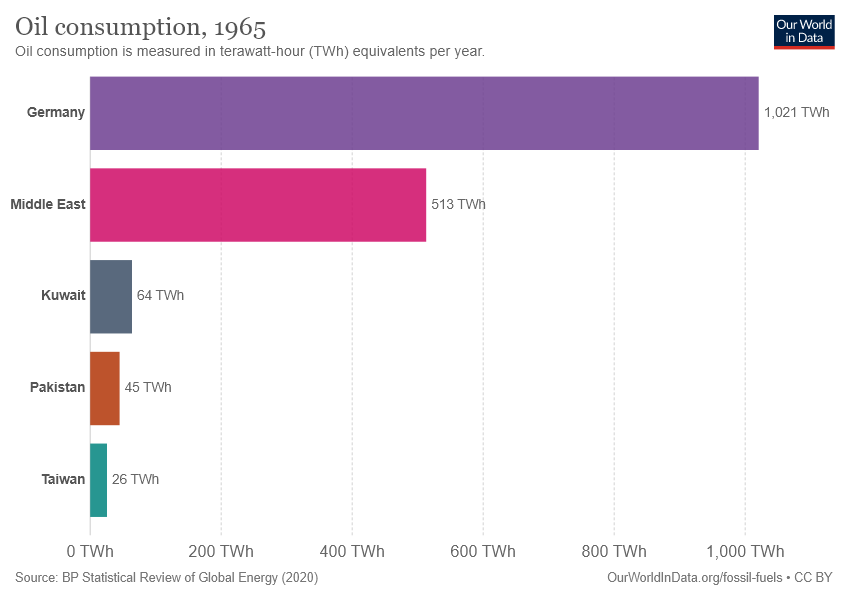Point out several critical features in this image. There are 5 colors on the bar. The highest value of the Middle East is 513. 